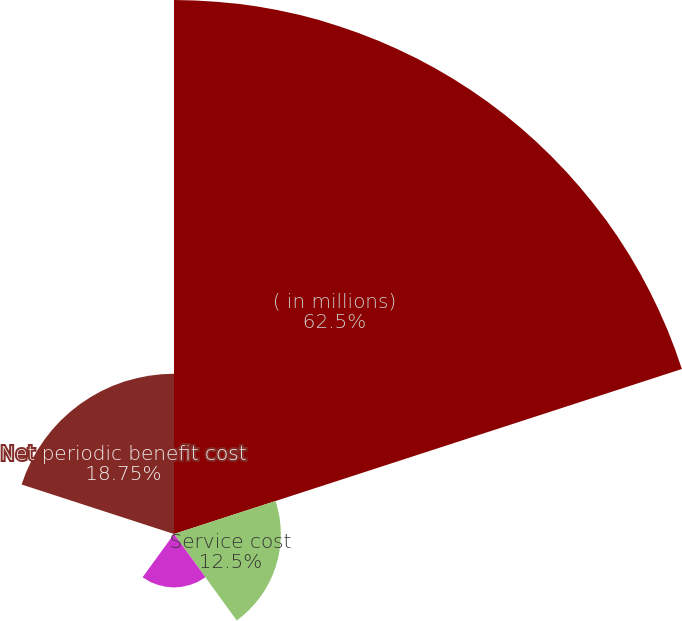<chart> <loc_0><loc_0><loc_500><loc_500><pie_chart><fcel>( in millions)<fcel>Service cost<fcel>Interest cost<fcel>Amortization of prior service<fcel>Net periodic benefit cost<nl><fcel>62.49%<fcel>12.5%<fcel>6.25%<fcel>0.0%<fcel>18.75%<nl></chart> 